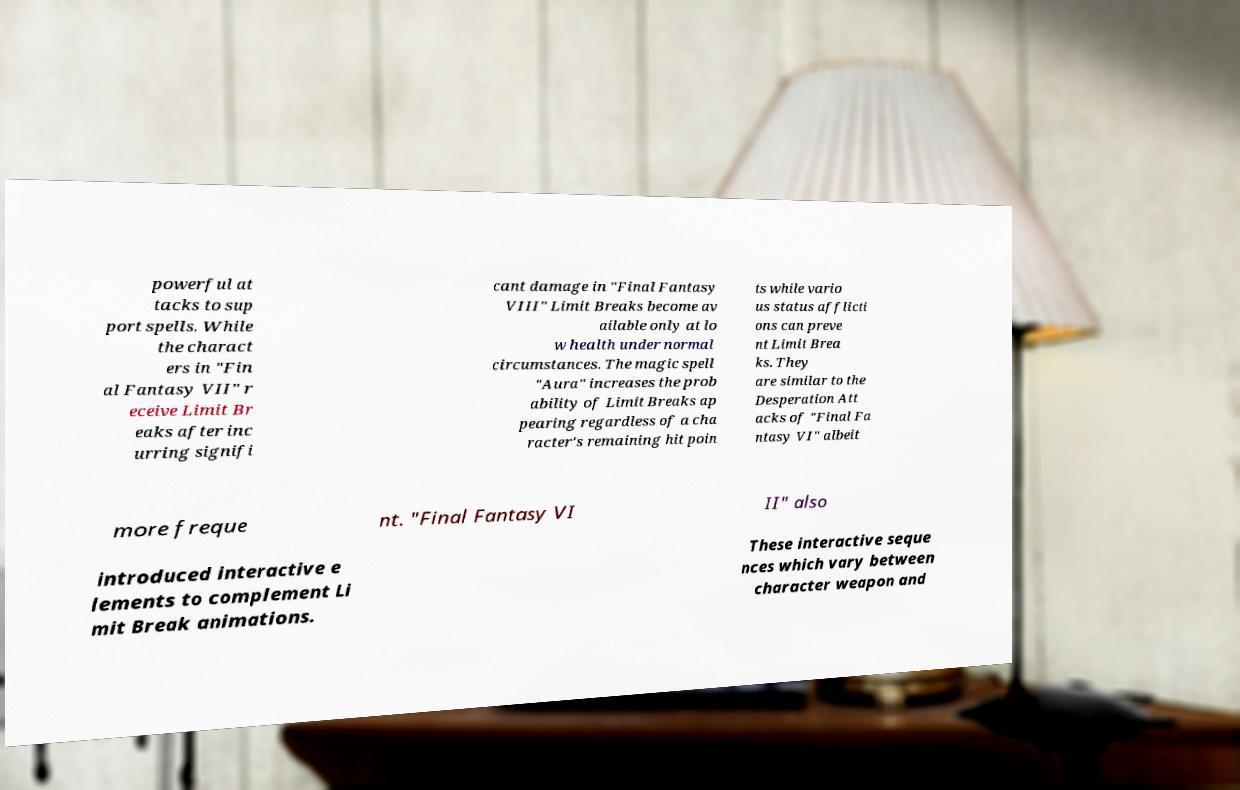There's text embedded in this image that I need extracted. Can you transcribe it verbatim? powerful at tacks to sup port spells. While the charact ers in "Fin al Fantasy VII" r eceive Limit Br eaks after inc urring signifi cant damage in "Final Fantasy VIII" Limit Breaks become av ailable only at lo w health under normal circumstances. The magic spell "Aura" increases the prob ability of Limit Breaks ap pearing regardless of a cha racter's remaining hit poin ts while vario us status afflicti ons can preve nt Limit Brea ks. They are similar to the Desperation Att acks of "Final Fa ntasy VI" albeit more freque nt. "Final Fantasy VI II" also introduced interactive e lements to complement Li mit Break animations. These interactive seque nces which vary between character weapon and 